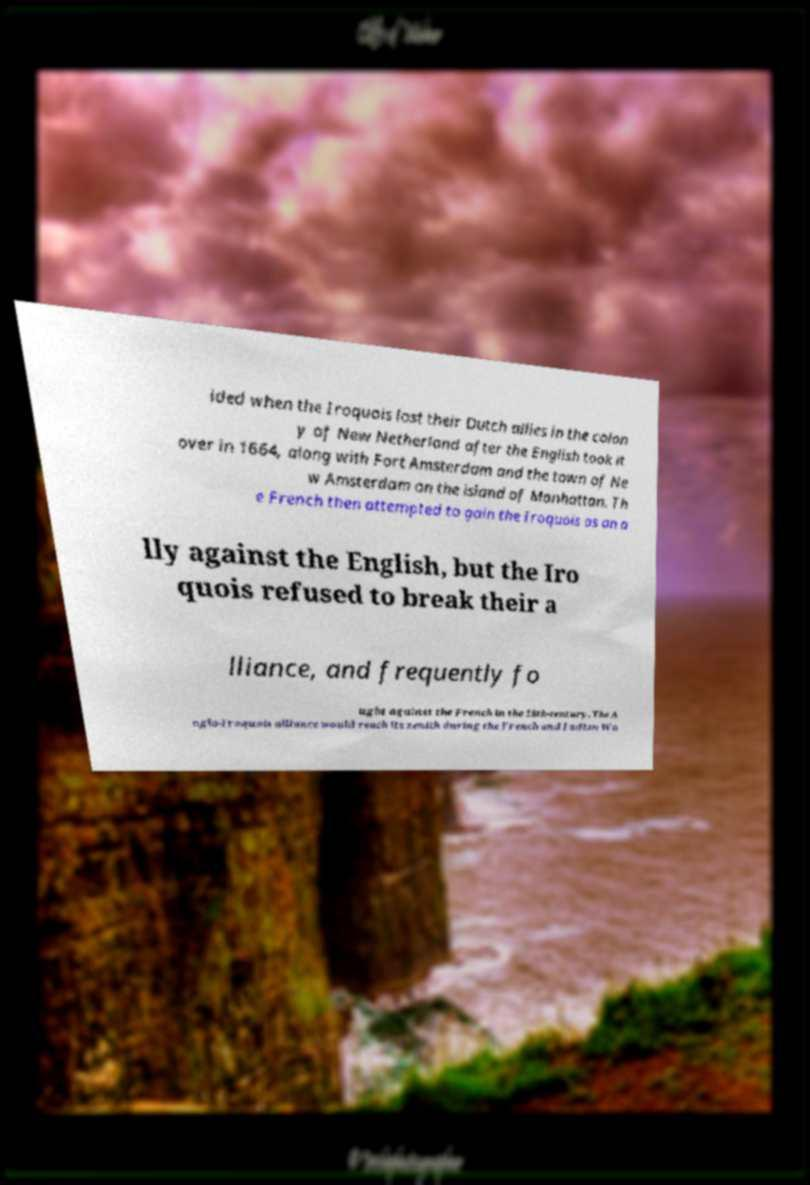Could you extract and type out the text from this image? ided when the Iroquois lost their Dutch allies in the colon y of New Netherland after the English took it over in 1664, along with Fort Amsterdam and the town of Ne w Amsterdam on the island of Manhattan. Th e French then attempted to gain the Iroquois as an a lly against the English, but the Iro quois refused to break their a lliance, and frequently fo ught against the French in the 18th-century. The A nglo-Iroquois alliance would reach its zenith during the French and Indian Wa 